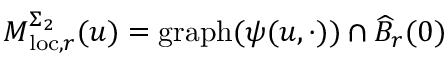Convert formula to latex. <formula><loc_0><loc_0><loc_500><loc_500>M _ { l o c , r } ^ { \Sigma _ { 2 } } ( u ) = g r a p h ( { \psi } ( u , \cdot ) ) \cap \widehat { B } _ { r } ( 0 )</formula> 